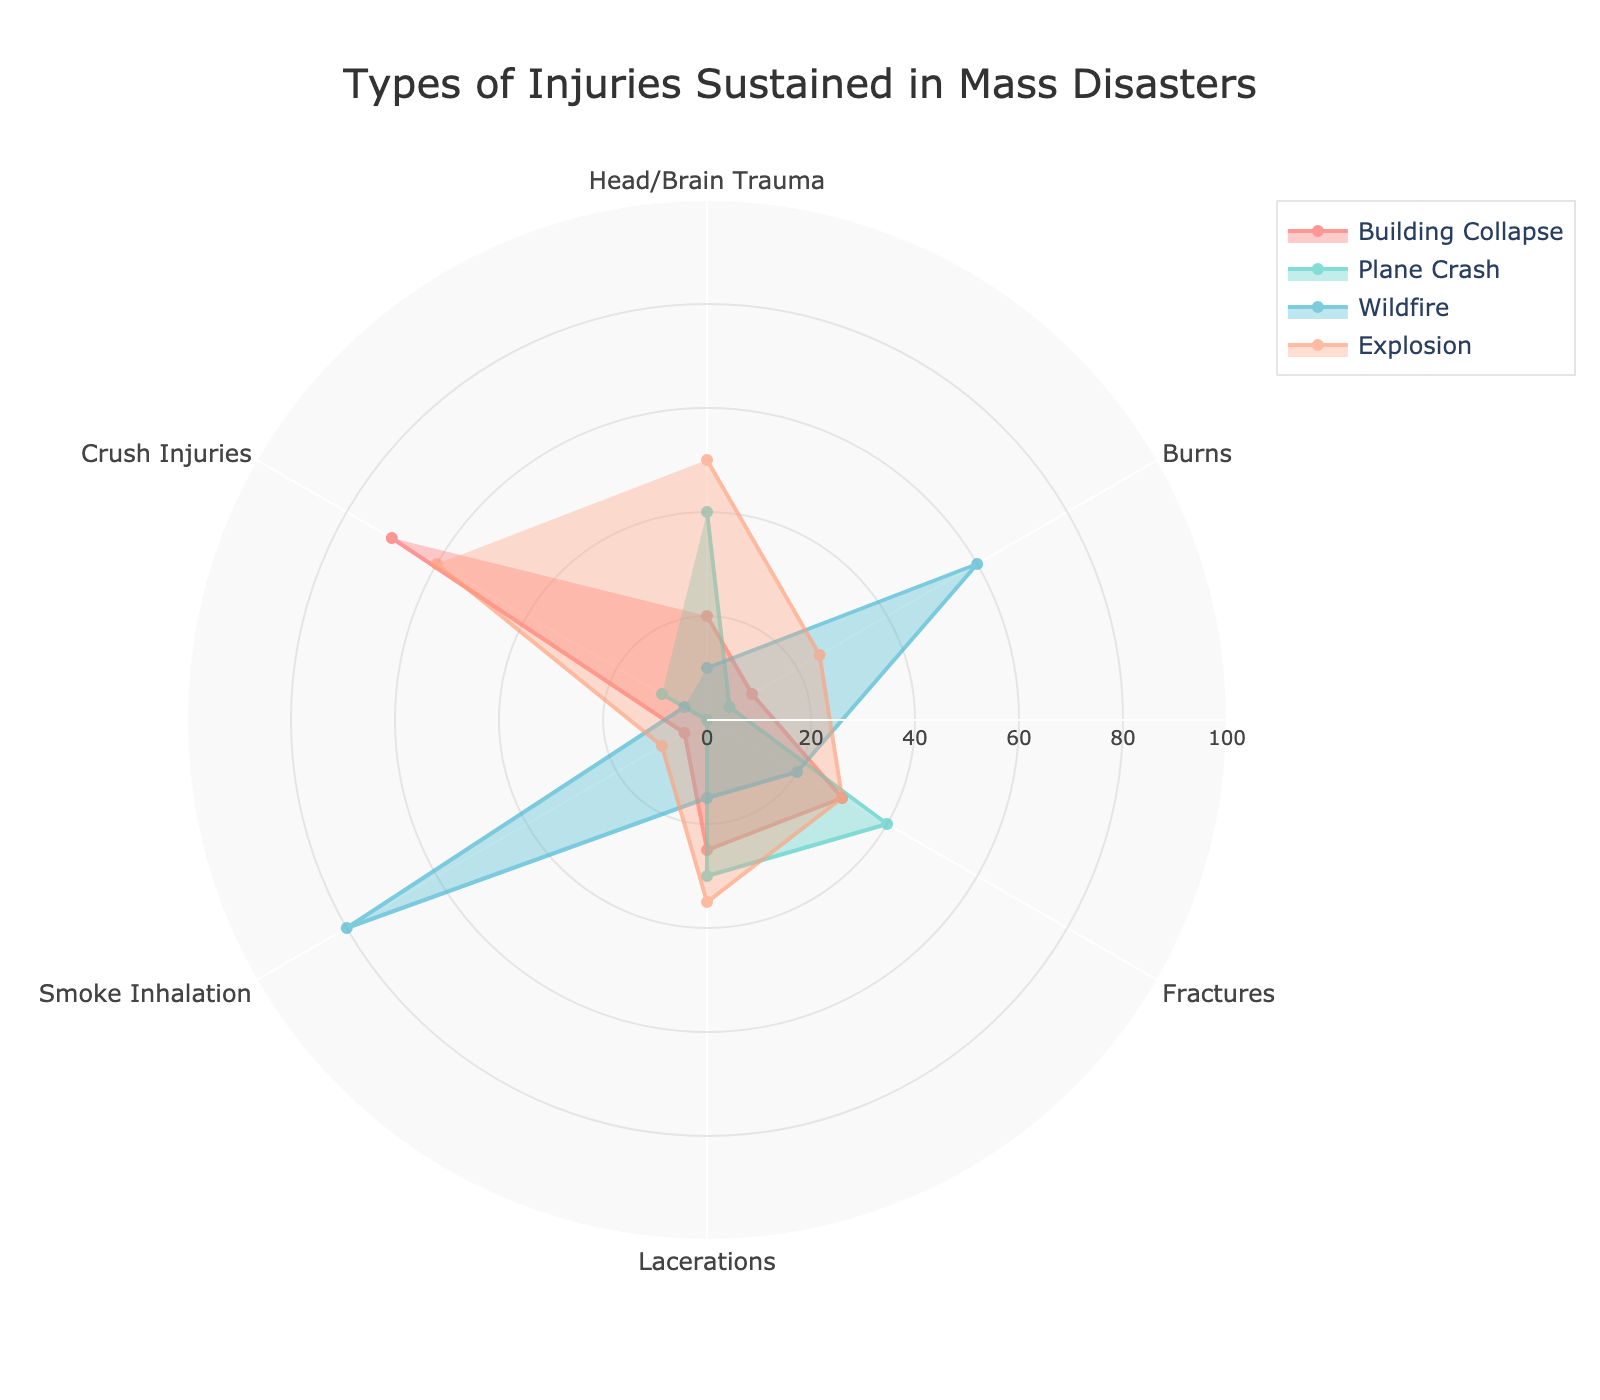What is the title of the chart? The chart's title is usually placed at the top of the visual, indicating its main focus or subject.
Answer: Types of Injuries Sustained in Mass Disasters Which type of injury has the highest value in Explosion? First, identify the segment labeled "Explosion". Then, find the point on the chart that extends the farthest from the center in that segment.
Answer: Head/Brain Trauma and Crush Injuries (both 60) How many data points are represented in the Building Collapse segment? Each type of injury forms a data point within each disaster segment. Count the individual segments for "Building Collapse".
Answer: 6 Among the four types of disasters, which one has the highest count in Smoke Inhalation? Compare the radial lengths associated with "Smoke Inhalation" in all disaster segments and identify the longest one.
Answer: Wildfire What is the sum of Fractures and Lacerations for Plane Crash? Add the values for "Fractures" and "Lacerations" in the Plane Crash segment (40 for Fractures and 30 for Lacerations).
Answer: 70 Which disaster segment has the least count for Crush Injuries? Compare the radial lengths for "Crush Injuries" and find the shortest one among the categories.
Answer: Wildfire What is the average value of the injuries reported under Wildfire? Add all values for Wildfire, then divide by the number of injury types (10 + 60 + 20 + 15 + 80 + 5 = 190; 190 / 6).
Answer: 31.67 Which type of injury has the lowest count overall? Identify the minimal value in the entire chart across all segments.
Answer: Smoke Inhalation in Plane Crash (0) Between Building Collapse and Explosion, which type of injury shows the largest difference? For each type of injury, calculate the absolute difference between the values reported for Building Collapse and Explosion. Identify the maximum difference.
Answer: Smoke Inhalation (55) Is the number of Burns in Explosion greater than the number of Head/Brain Trauma in Wildfire? Compare the counts: Burns in Explosion is 25, whereas Head/Brain Trauma in Wildfire is 10.
Answer: Yes 